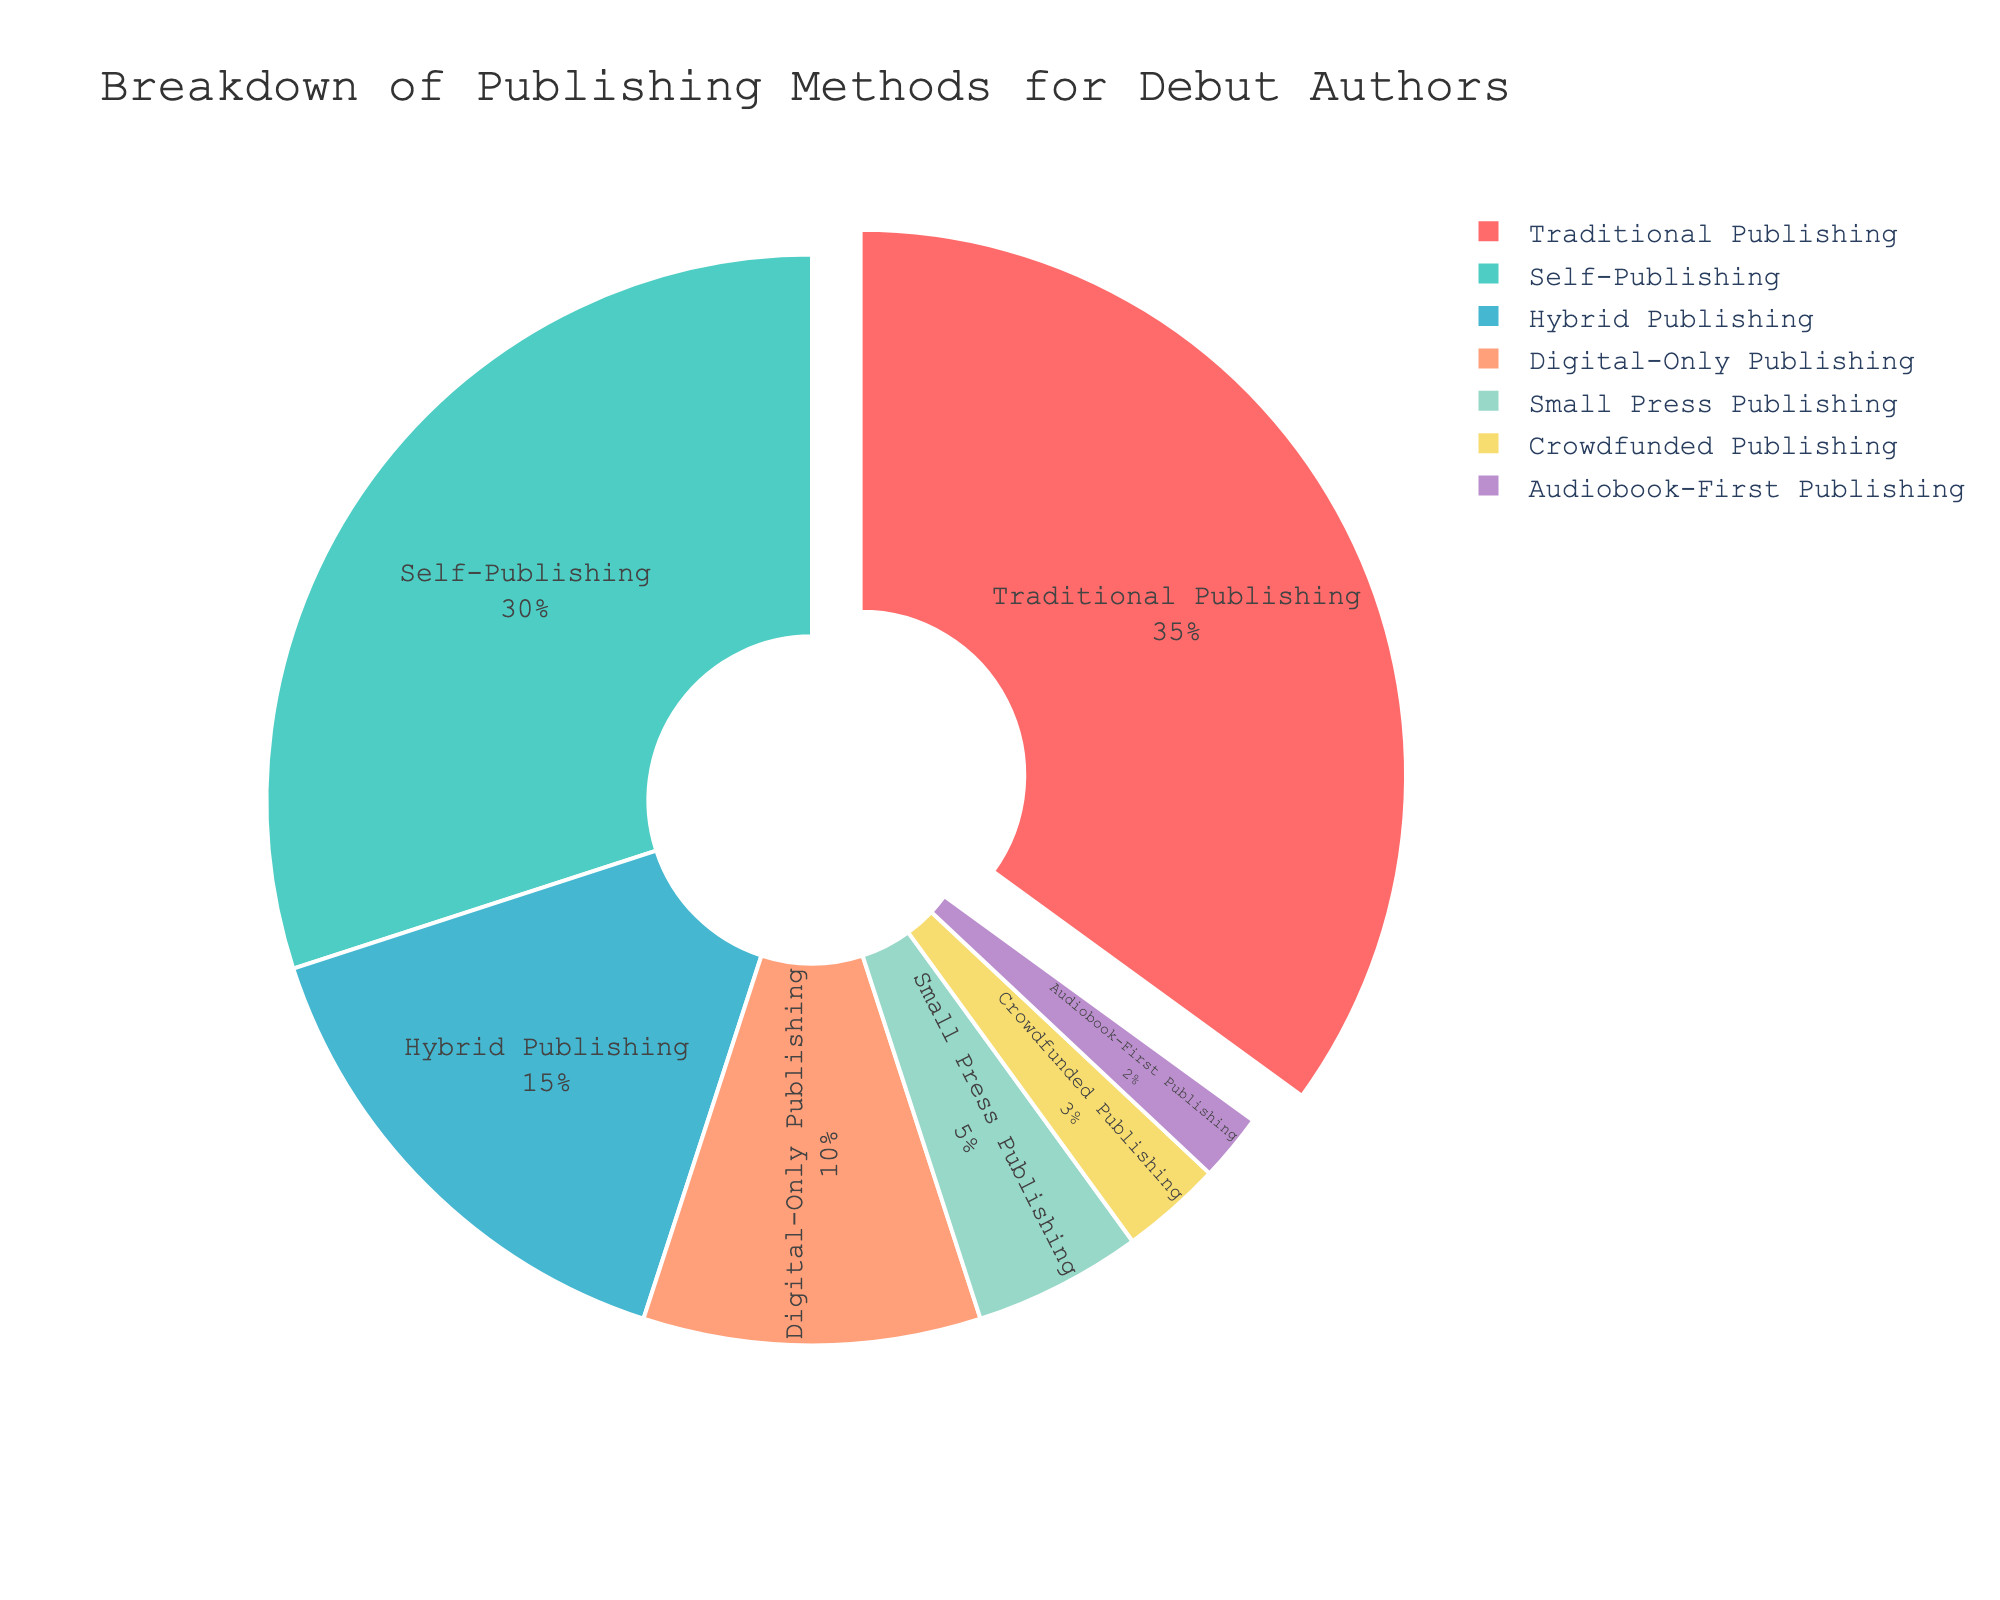What's the most popular publishing method among debut authors? The figure shows various publishing methods with corresponding percentages. The method with the highest percentage is the most popular. Traditional Publishing has the highest percentage at 35%.
Answer: Traditional Publishing What's the combined percentage of Self-Publishing and Hybrid Publishing? To find the combined percentage, add the percentage values of Self-Publishing (30%) and Hybrid Publishing (15%). This totals to 30 + 15 = 45%.
Answer: 45% Which publishing method is less common: Crowdfunded Publishing or Audiobook-First Publishing? Compare the two given methods' percentages. Crowdfunded Publishing is at 3% while Audiobook-First Publishing is at 2%. Since 2% is smaller than 3%, Audiobook-First Publishing is less common.
Answer: Audiobook-First Publishing How much more popular is Traditional Publishing compared to Small Press Publishing? Subtract the percentage of Small Press Publishing (5%) from Traditional Publishing (35%). This results in 35 - 5 = 30%.
Answer: 30% Which three methods together make up exactly 60% of the debut authors’ choices? To find three methods that together make up 60%, check combinations of percentages. Self-Publishing (30%), Hybrid Publishing (15%), and Digital-Only Publishing (10%) total to 30 + 15 + 10 = 55%. Next, Traditional Publishing (35%), Small Press Publishing (5%), and Crowdfunded Publishing (3%) total to 35 + 5 + 3 = 43%. Traditional Publishing (35%), Self-Publishing (30%), and Digital-Only Publishing (10%) total to 35 + 30 + 10 = 75%. Finally, Self-Publishing (30%), Hybrid Publishing (15%), and Digital-Only Publishing (10%) total to 30 + 15 + 10 = 55%, Digital-Only Publishing (10%), Small Press Publishing (5%), and Crowdfunded Publishing (3%) totals to 10 + 5 + 3 = 18%. Trying Traditional Publishing (35%), Digital-Only Publishing (10%), and Hybrid Publishing (15%) total to 35 + 10 + 15 = 60%.
Answer: Traditional Publishing, Hybrid Publishing, Digital-Only Publishing Which method corresponds to the light blue color in the chart? Observing the pie chart, the light blue slice belongs to the publishing method where the color is assigned. Identify the method's name by locating the color's corresponding segment. Self-Publishing is indicated by light blue in the chart.
Answer: Self-Publishing What fraction of the authors chose Audiobook-First Publishing? To determine the fraction, convert the percentage of Audiobook-First Publishing (2%) to a fraction. 2% is equivalent to 2/100, which simplifies to 1/50.
Answer: 1/50 